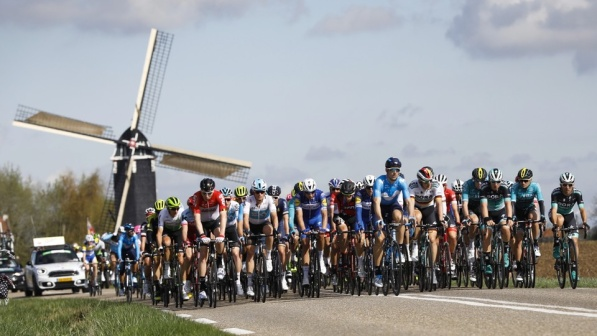What is this photo about? In the image, a dynamic group of cyclists is actively pedaling along a gray road. Their colorful jerseys and helmets add a vibrant and lively touch to the scene. The cyclists are riding closely together, indicating a strong sense of camaraderie or a competitive atmosphere, likely part of a race or a group ride. On the left side of the road stands a majestic windmill with four white sails, its traditional design providing a splendid contrast to the clear blue sky dotted with fluffy clouds. The road is flanked by green grass, which frames the scene beautifully. This visual depiction captures a spirited moment of activity and energy set against a picturesque backdrop of natural beauty and architectural heritage, suggesting the cyclists are on a notable journey or participating in a race. 